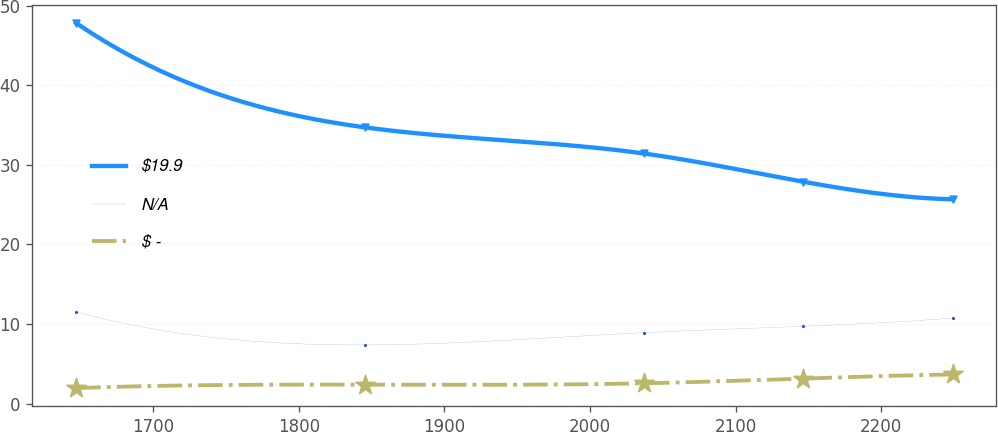<chart> <loc_0><loc_0><loc_500><loc_500><line_chart><ecel><fcel>$19.9<fcel>N/A<fcel>$ -<nl><fcel>1647.01<fcel>47.8<fcel>11.52<fcel>1.94<nl><fcel>1845.61<fcel>34.69<fcel>7.36<fcel>2.37<nl><fcel>2036.77<fcel>31.42<fcel>8.9<fcel>2.54<nl><fcel>2146.33<fcel>27.87<fcel>9.7<fcel>3.14<nl><fcel>2249.06<fcel>25.66<fcel>10.74<fcel>3.65<nl></chart> 